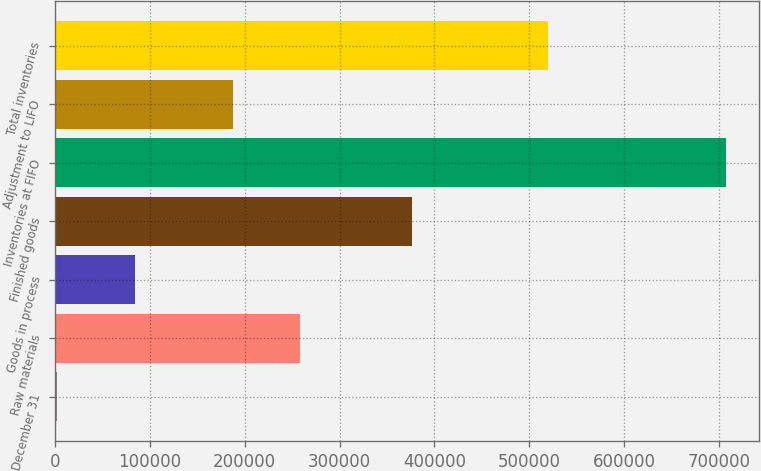Convert chart to OTSL. <chart><loc_0><loc_0><loc_500><loc_500><bar_chart><fcel>December 31<fcel>Raw materials<fcel>Goods in process<fcel>Finished goods<fcel>Inventories at FIFO<fcel>Adjustment to LIFO<fcel>Total inventories<nl><fcel>2009<fcel>257947<fcel>84000<fcel>376573<fcel>707145<fcel>187433<fcel>519712<nl></chart> 